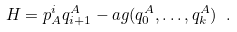<formula> <loc_0><loc_0><loc_500><loc_500>H = p ^ { i } _ { A } q _ { i + 1 } ^ { A } - \L a g ( q _ { 0 } ^ { A } , \dots , q _ { k } ^ { A } ) \ .</formula> 